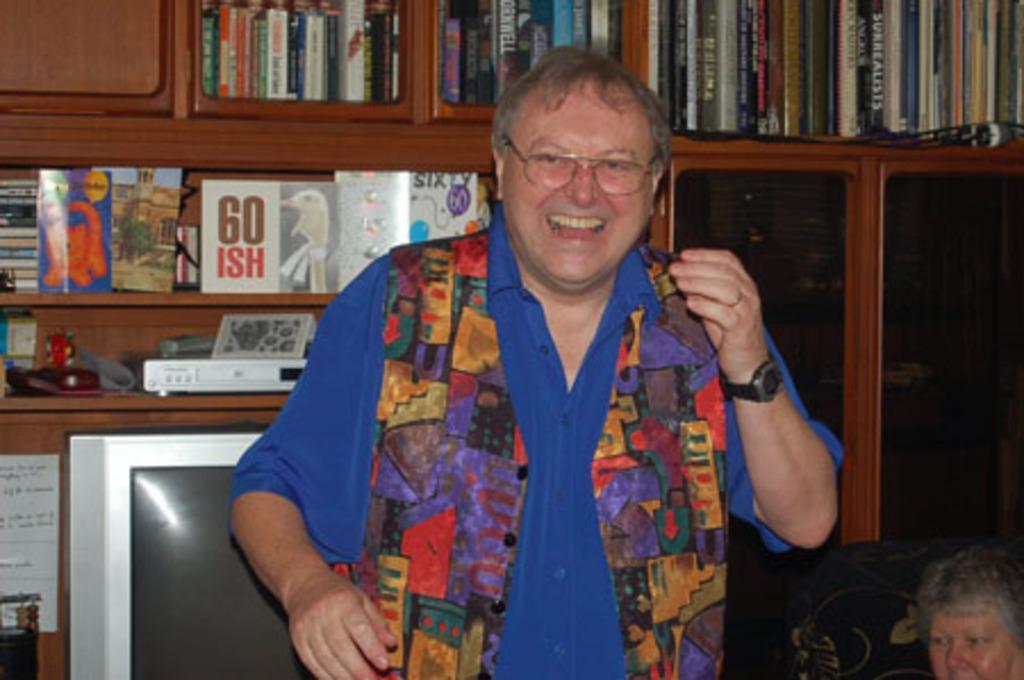In one or two sentences, can you explain what this image depicts? This picture seems to be clicked inside the room. In the center we can see a person wearing blue color shirt, smiling and standing. On the right corner we can see another person. In the background we can see the wooden cabinet containing books and some other objects and we can see some electronic devices and the text and numbers on the books. 